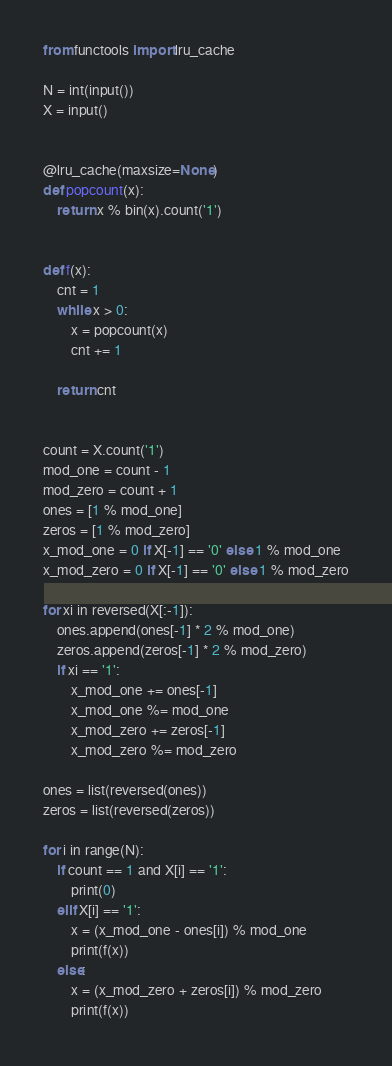Convert code to text. <code><loc_0><loc_0><loc_500><loc_500><_Python_>from functools import lru_cache

N = int(input())
X = input()


@lru_cache(maxsize=None)
def popcount(x):
    return x % bin(x).count('1')


def f(x):
    cnt = 1
    while x > 0:
        x = popcount(x)
        cnt += 1

    return cnt


count = X.count('1')
mod_one = count - 1
mod_zero = count + 1
ones = [1 % mod_one]
zeros = [1 % mod_zero]
x_mod_one = 0 if X[-1] == '0' else 1 % mod_one
x_mod_zero = 0 if X[-1] == '0' else 1 % mod_zero

for xi in reversed(X[:-1]):
    ones.append(ones[-1] * 2 % mod_one)
    zeros.append(zeros[-1] * 2 % mod_zero)
    if xi == '1':
        x_mod_one += ones[-1]
        x_mod_one %= mod_one
        x_mod_zero += zeros[-1]
        x_mod_zero %= mod_zero

ones = list(reversed(ones))
zeros = list(reversed(zeros))

for i in range(N):
    if count == 1 and X[i] == '1':
        print(0)
    elif X[i] == '1':
        x = (x_mod_one - ones[i]) % mod_one
        print(f(x))
    else:
        x = (x_mod_zero + zeros[i]) % mod_zero
        print(f(x))
</code> 